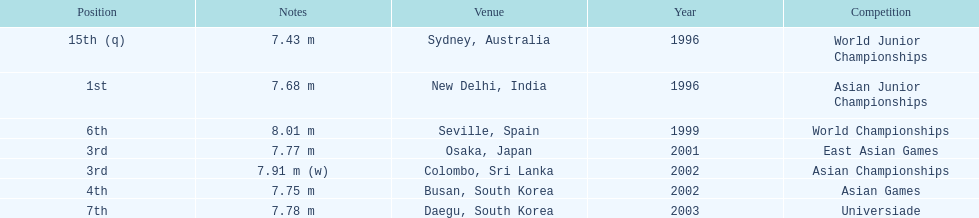Would you be able to parse every entry in this table? {'header': ['Position', 'Notes', 'Venue', 'Year', 'Competition'], 'rows': [['15th (q)', '7.43 m', 'Sydney, Australia', '1996', 'World Junior Championships'], ['1st', '7.68 m', 'New Delhi, India', '1996', 'Asian Junior Championships'], ['6th', '8.01 m', 'Seville, Spain', '1999', 'World Championships'], ['3rd', '7.77 m', 'Osaka, Japan', '2001', 'East Asian Games'], ['3rd', '7.91 m (w)', 'Colombo, Sri Lanka', '2002', 'Asian Championships'], ['4th', '7.75 m', 'Busan, South Korea', '2002', 'Asian Games'], ['7th', '7.78 m', 'Daegu, South Korea', '2003', 'Universiade']]} What is the distinction between the number of times the third position was attained and the number of times the first position was reached? 1. 